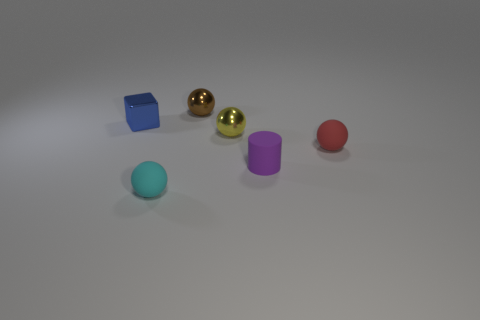There is a small cyan sphere; are there any matte balls right of it?
Offer a terse response. Yes. There is a small rubber thing in front of the tiny cylinder; is there a rubber thing that is behind it?
Your answer should be compact. Yes. There is a object behind the tiny cube; is its size the same as the matte sphere that is on the left side of the small red matte object?
Provide a succinct answer. Yes. What number of big objects are blue shiny cubes or cyan balls?
Provide a short and direct response. 0. There is a tiny cube that is in front of the brown metal sphere behind the cyan rubber object; what is it made of?
Provide a short and direct response. Metal. Is there a blue thing that has the same material as the brown object?
Offer a very short reply. Yes. Is the blue thing made of the same material as the thing on the right side of the matte cylinder?
Offer a terse response. No. There is a cube that is the same size as the brown ball; what color is it?
Provide a short and direct response. Blue. What size is the metal thing on the left side of the rubber sphere on the left side of the red matte sphere?
Offer a terse response. Small. Are there fewer tiny brown spheres in front of the purple cylinder than small yellow metallic objects?
Offer a terse response. Yes. 